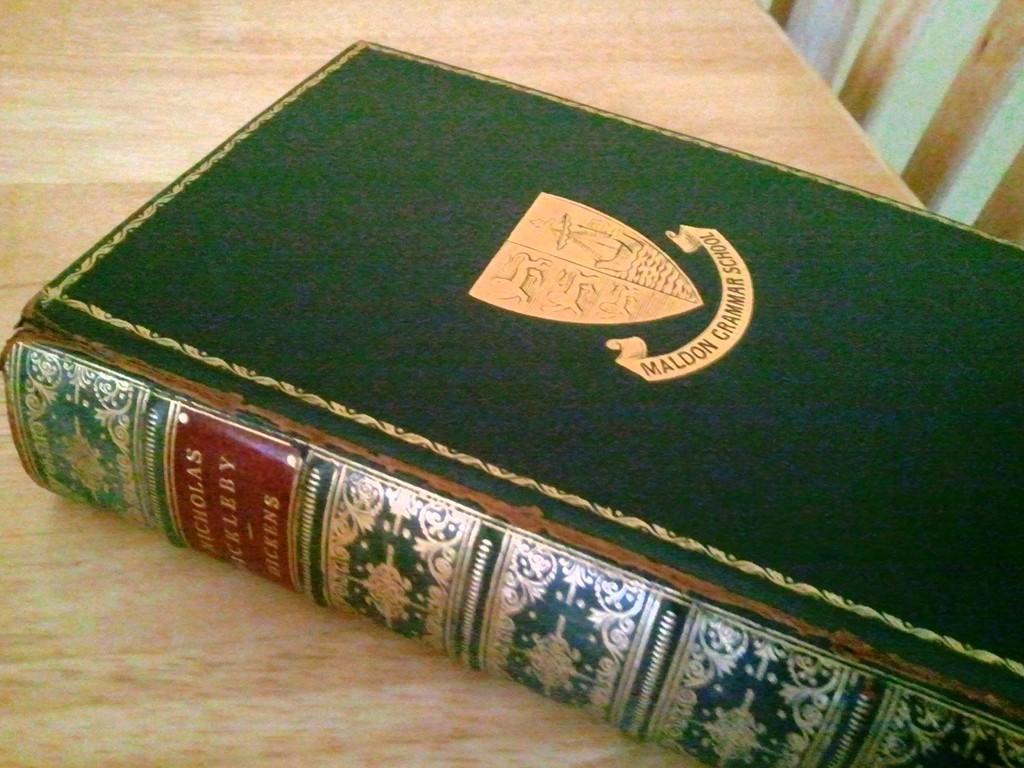What is the school's name on the front cover of the book?
Offer a terse response. Maldon grammar school. Whats the logo about?
Provide a short and direct response. Maldon grammar school. 